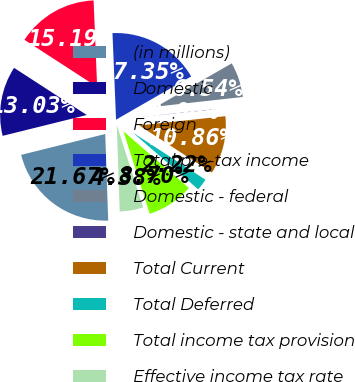Convert chart to OTSL. <chart><loc_0><loc_0><loc_500><loc_500><pie_chart><fcel>(in millions)<fcel>Domestic<fcel>Foreign<fcel>Total pre-tax income<fcel>Domestic - federal<fcel>Domestic - state and local<fcel>Total Current<fcel>Total Deferred<fcel>Total income tax provision<fcel>Effective income tax rate<nl><fcel>21.66%<fcel>13.02%<fcel>15.18%<fcel>17.34%<fcel>6.54%<fcel>0.06%<fcel>10.86%<fcel>2.22%<fcel>8.7%<fcel>4.38%<nl></chart> 